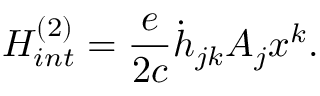<formula> <loc_0><loc_0><loc_500><loc_500>H _ { i n t } ^ { ( 2 ) } = \frac { e } { 2 c } \dot { h } _ { j k } A _ { j } x ^ { k } .</formula> 